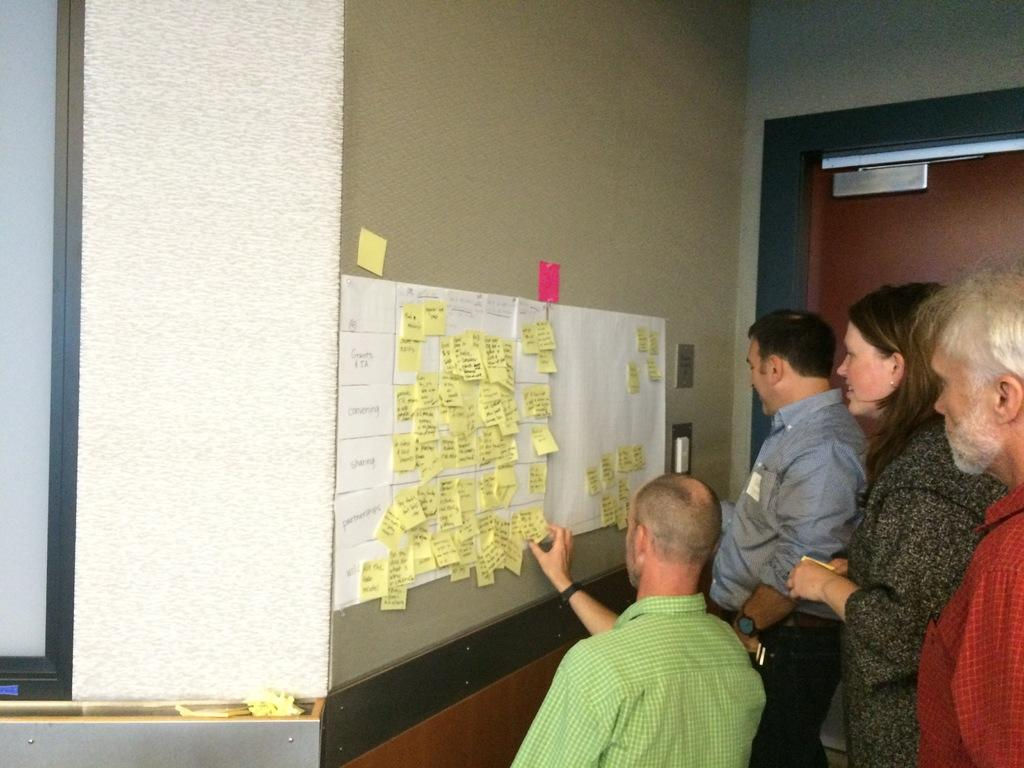How many people are present in the image? There are four people in the image. What are the people wearing? The people are wearing clothes. What is in front of the people? There is a wall in front of the people. What can be seen on the wall? White charts are stuck to the wall, and there are yellow stickers visible. Where is the door located in the image? There is a door in the image. What type of zipper can be seen on the ship in the image? There is no ship or zipper present in the image. What system is being used by the people to communicate in the image? The image does not provide information about any communication system being used by the people. 